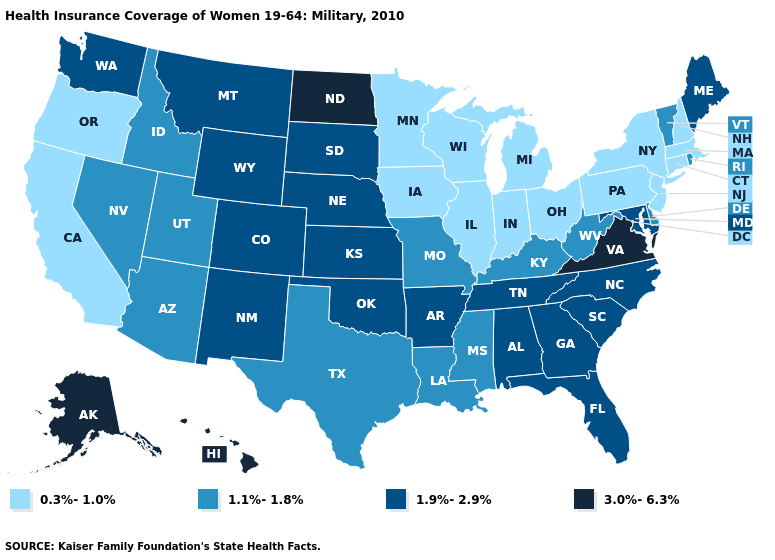Among the states that border Illinois , which have the lowest value?
Concise answer only. Indiana, Iowa, Wisconsin. What is the lowest value in the Northeast?
Concise answer only. 0.3%-1.0%. Does Connecticut have a lower value than Montana?
Give a very brief answer. Yes. Name the states that have a value in the range 1.9%-2.9%?
Write a very short answer. Alabama, Arkansas, Colorado, Florida, Georgia, Kansas, Maine, Maryland, Montana, Nebraska, New Mexico, North Carolina, Oklahoma, South Carolina, South Dakota, Tennessee, Washington, Wyoming. What is the highest value in states that border Utah?
Answer briefly. 1.9%-2.9%. Is the legend a continuous bar?
Quick response, please. No. Name the states that have a value in the range 3.0%-6.3%?
Quick response, please. Alaska, Hawaii, North Dakota, Virginia. What is the value of Connecticut?
Quick response, please. 0.3%-1.0%. Name the states that have a value in the range 3.0%-6.3%?
Keep it brief. Alaska, Hawaii, North Dakota, Virginia. Name the states that have a value in the range 3.0%-6.3%?
Keep it brief. Alaska, Hawaii, North Dakota, Virginia. Name the states that have a value in the range 1.9%-2.9%?
Concise answer only. Alabama, Arkansas, Colorado, Florida, Georgia, Kansas, Maine, Maryland, Montana, Nebraska, New Mexico, North Carolina, Oklahoma, South Carolina, South Dakota, Tennessee, Washington, Wyoming. Does Missouri have the lowest value in the MidWest?
Keep it brief. No. What is the value of Louisiana?
Give a very brief answer. 1.1%-1.8%. Name the states that have a value in the range 1.1%-1.8%?
Short answer required. Arizona, Delaware, Idaho, Kentucky, Louisiana, Mississippi, Missouri, Nevada, Rhode Island, Texas, Utah, Vermont, West Virginia. Name the states that have a value in the range 1.1%-1.8%?
Give a very brief answer. Arizona, Delaware, Idaho, Kentucky, Louisiana, Mississippi, Missouri, Nevada, Rhode Island, Texas, Utah, Vermont, West Virginia. 